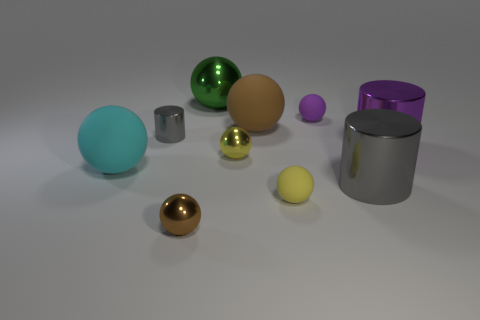Subtract all cyan spheres. How many spheres are left? 6 Subtract 1 cylinders. How many cylinders are left? 2 Subtract all green balls. How many balls are left? 6 Subtract all gray balls. Subtract all gray cubes. How many balls are left? 7 Subtract all cylinders. How many objects are left? 7 Add 9 large brown metal things. How many large brown metal things exist? 9 Subtract 0 red cylinders. How many objects are left? 10 Subtract all brown metal balls. Subtract all purple objects. How many objects are left? 7 Add 3 large gray things. How many large gray things are left? 4 